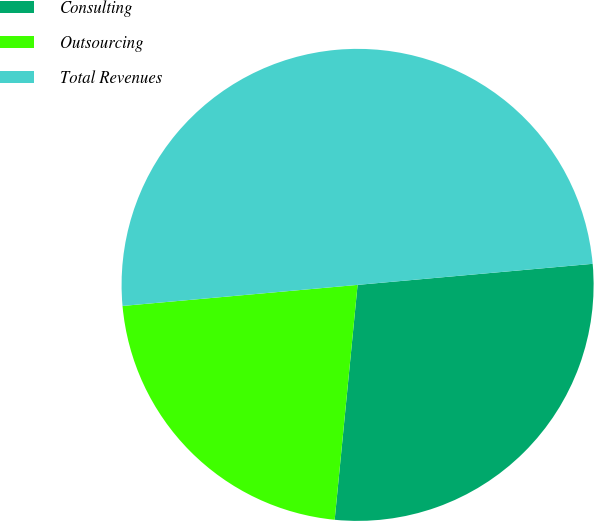Convert chart. <chart><loc_0><loc_0><loc_500><loc_500><pie_chart><fcel>Consulting<fcel>Outsourcing<fcel>Total Revenues<nl><fcel>27.97%<fcel>22.03%<fcel>50.0%<nl></chart> 